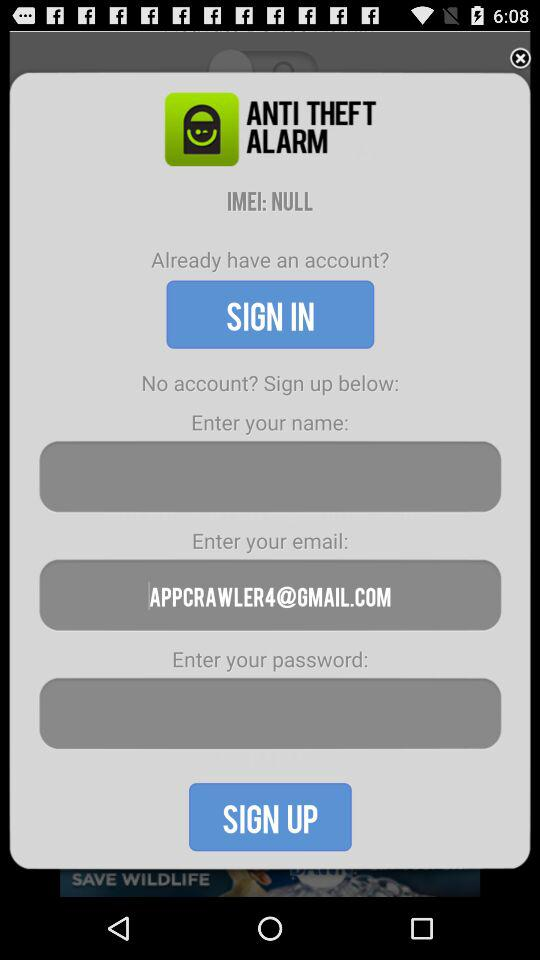What is the IMEI number? The IMEI number is "NULL". 